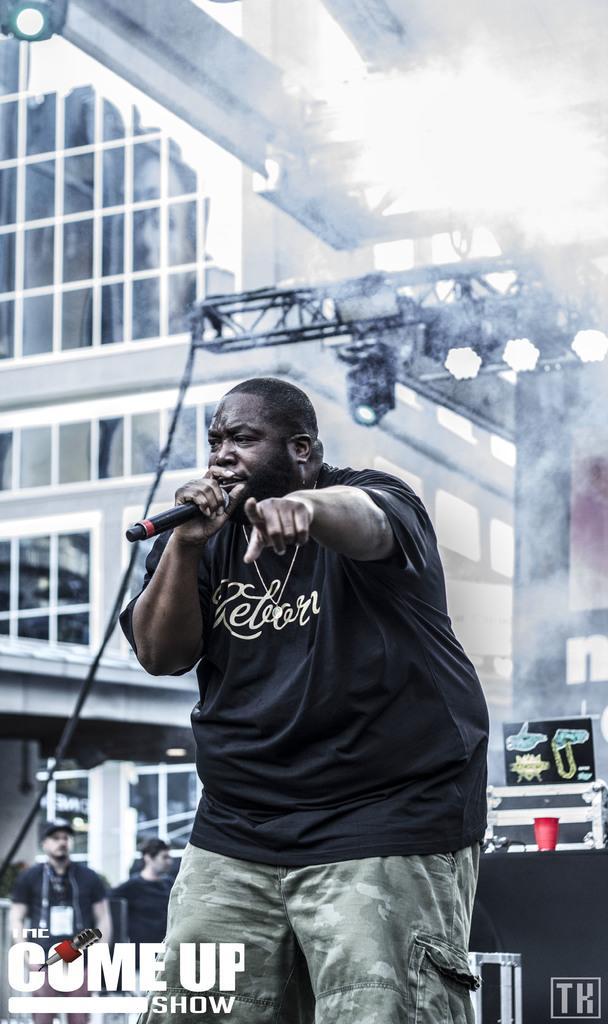Please provide a concise description of this image. In this image I can see a man wearing black t shirt and also holding a mic. In the background I can see few more people and few lights. 